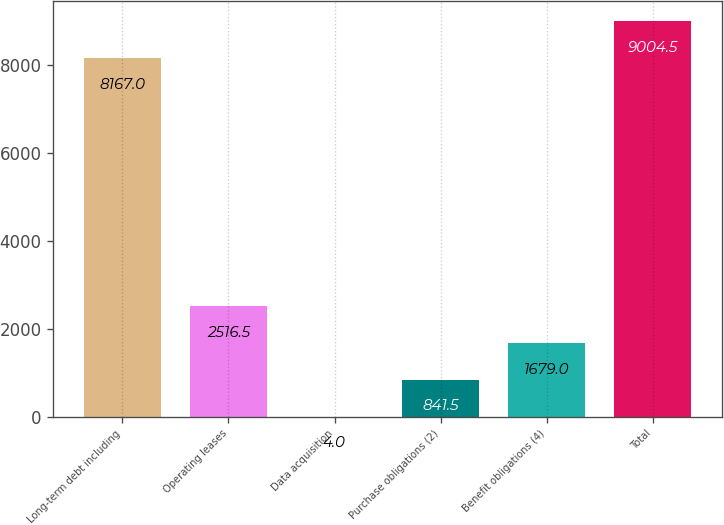Convert chart. <chart><loc_0><loc_0><loc_500><loc_500><bar_chart><fcel>Long-term debt including<fcel>Operating leases<fcel>Data acquisition<fcel>Purchase obligations (2)<fcel>Benefit obligations (4)<fcel>Total<nl><fcel>8167<fcel>2516.5<fcel>4<fcel>841.5<fcel>1679<fcel>9004.5<nl></chart> 